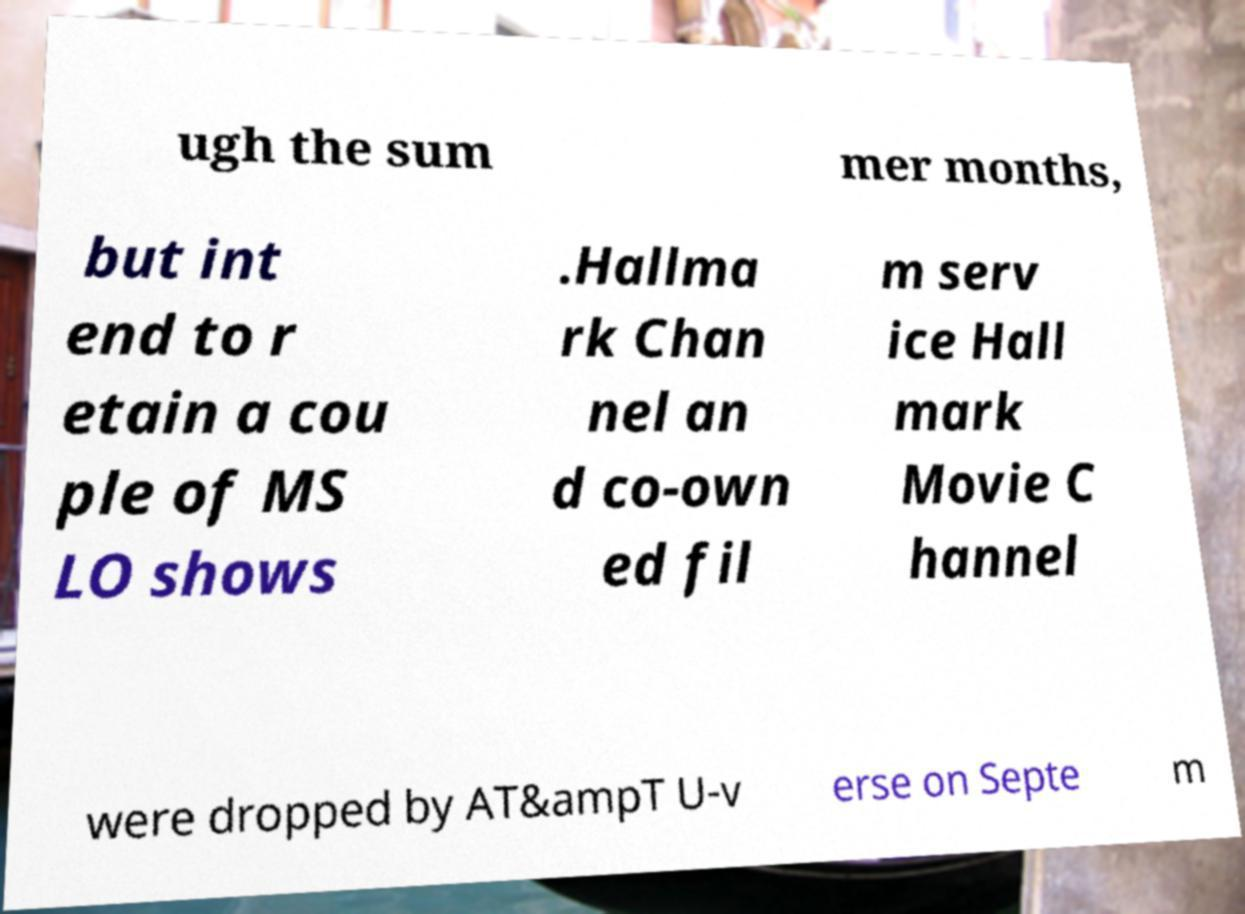Please read and relay the text visible in this image. What does it say? ugh the sum mer months, but int end to r etain a cou ple of MS LO shows .Hallma rk Chan nel an d co-own ed fil m serv ice Hall mark Movie C hannel were dropped by AT&ampT U-v erse on Septe m 